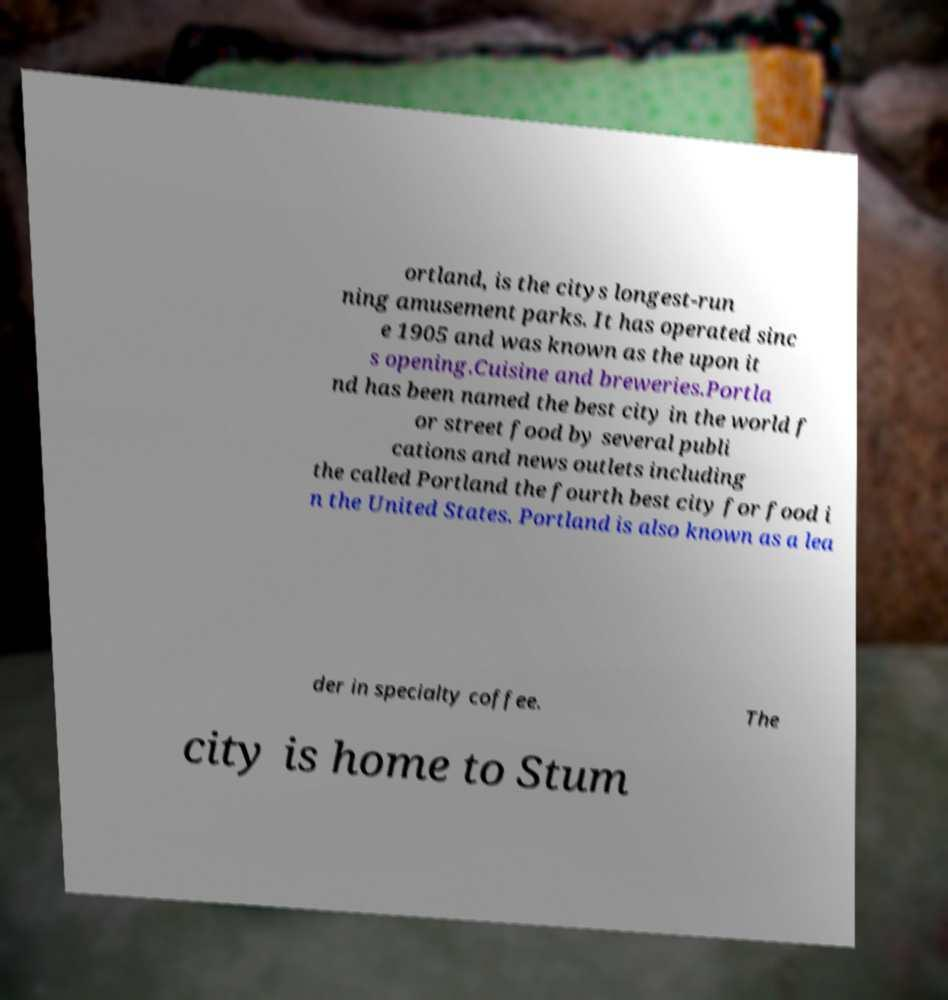I need the written content from this picture converted into text. Can you do that? ortland, is the citys longest-run ning amusement parks. It has operated sinc e 1905 and was known as the upon it s opening.Cuisine and breweries.Portla nd has been named the best city in the world f or street food by several publi cations and news outlets including the called Portland the fourth best city for food i n the United States. Portland is also known as a lea der in specialty coffee. The city is home to Stum 